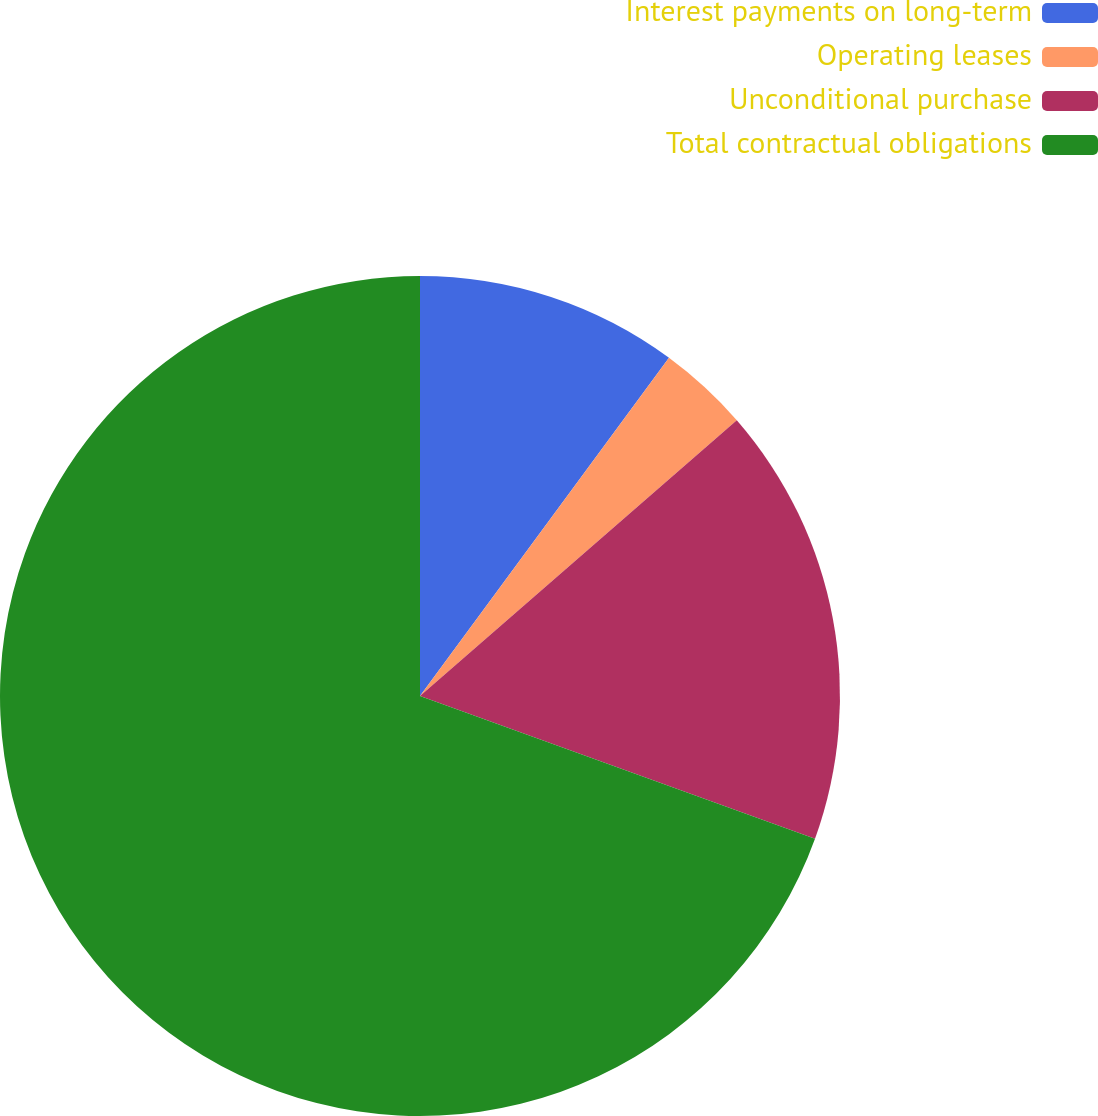Convert chart. <chart><loc_0><loc_0><loc_500><loc_500><pie_chart><fcel>Interest payments on long-term<fcel>Operating leases<fcel>Unconditional purchase<fcel>Total contractual obligations<nl><fcel>10.1%<fcel>3.5%<fcel>16.92%<fcel>69.48%<nl></chart> 